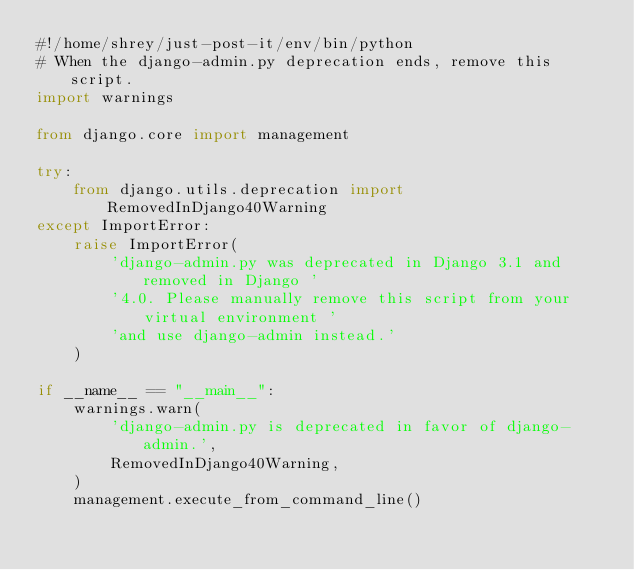<code> <loc_0><loc_0><loc_500><loc_500><_Python_>#!/home/shrey/just-post-it/env/bin/python
# When the django-admin.py deprecation ends, remove this script.
import warnings

from django.core import management

try:
    from django.utils.deprecation import RemovedInDjango40Warning
except ImportError:
    raise ImportError(
        'django-admin.py was deprecated in Django 3.1 and removed in Django '
        '4.0. Please manually remove this script from your virtual environment '
        'and use django-admin instead.'
    )

if __name__ == "__main__":
    warnings.warn(
        'django-admin.py is deprecated in favor of django-admin.',
        RemovedInDjango40Warning,
    )
    management.execute_from_command_line()
</code> 